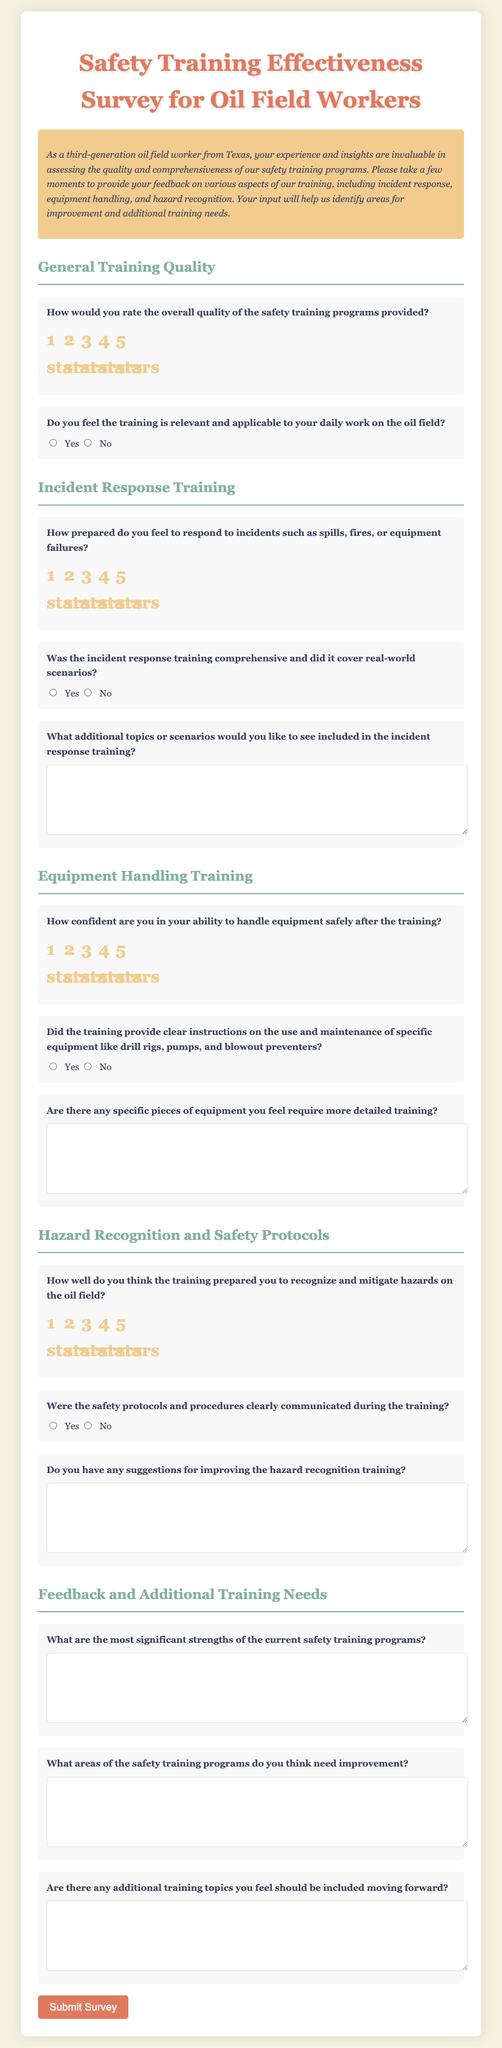What is the title of the survey? The title of the survey is stated at the top of the document and addresses the form's purpose.
Answer: Safety Training Effectiveness Survey for Oil Field Workers What section follows the General Training Quality? The document is organized into sections that address different aspects of safety training. This section includes Incident Response Training.
Answer: Incident Response Training How many stars can participants rate the overall quality of the safety training programs? The rating scale for the overall quality of the training programs ranges from 1 to 5 stars.
Answer: 5 What is one of the questions related to incident response training? The document presents several questions pertaining to incident response training, focusing on preparedness and comprehensiveness.
Answer: How prepared do you feel to respond to incidents such as spills, fires, or equipment failures? Are suggestions for improving hazard recognition training requested? The document includes specific sections asking for participant input on improvements, indicating a focus on gathering useful feedback.
Answer: Yes 